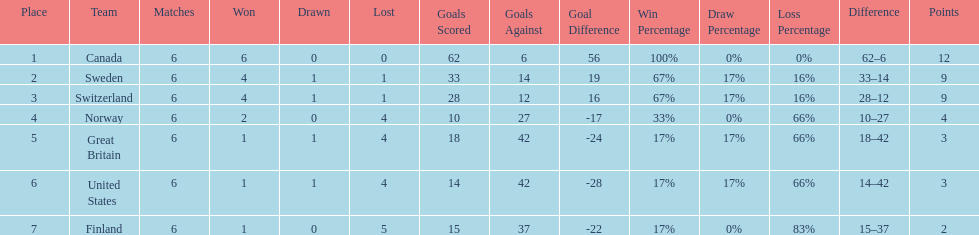Which country finished below the united states? Finland. 